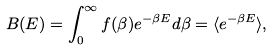<formula> <loc_0><loc_0><loc_500><loc_500>B ( E ) = \int _ { 0 } ^ { \infty } f ( \beta ) e ^ { - \beta E } d \beta = \langle e ^ { - \beta E } \rangle ,</formula> 